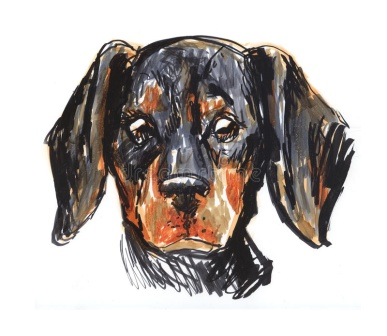What do you think the puppy might be thinking about? It's quite intriguing to imagine what the puppy might be thinking. Given its sad expression, it could be feeling a sense of loneliness or longing for companionship. Perhaps it's pondering over a recent adventure or waiting for its favorite person to return home. The depth in its eyes suggests a world of thoughts and emotions up for interpretation. What kind of environment do you think this puppy belongs to? This puppy could belong to a cozy home where it is cherished as a beloved pet. The detailed care in its illustration implies that it might live with a family that values it highly. Alternatively, the somber expression might suggest it has just been adopted from a shelter and is adjusting to its new loving home. Imagine a warm living room with soft sunlight pouring in, where this little dachshund finds its favorite spot to curl up. If this puppy could talk, what might it say? If this puppy could talk, it might say something like, 'Hello there! I'm feeling quite curious about you. Do you have any treats or stories to share? I promise to be a good listener.' It might also express a desire for companionship, saying, 'I could use a friend right now, someone to play with or just sit by my side. Your company means a lot to me.' Describe a day in the life of this puppy in a short story. Once upon a time, in a charming little house on the outskirts of town, lived a dachshund puppy named Rusty. Rusty would awaken each morning to the gentle sound of chirping birds, his floppy ears twitching as he stretched and yawned. His days were filled with playful jaunts in the garden, where he loved chasing butterflies and digging little holes in search of hidden treasures. In the afternoon, Rusty often settled on his favorite cushion, gazing out the window as he watched the world go by, his mind filled with dreams of grand adventures. Evenings were the best part of his day; Rusty eagerly awaited the return of his human family, his tail wagging furiously as they showered him with affection. Nestled in their arms, Rusty felt safe and cherished, and he drifted off to sleep with a contented heart, ready to embrace another day of joy and love. 